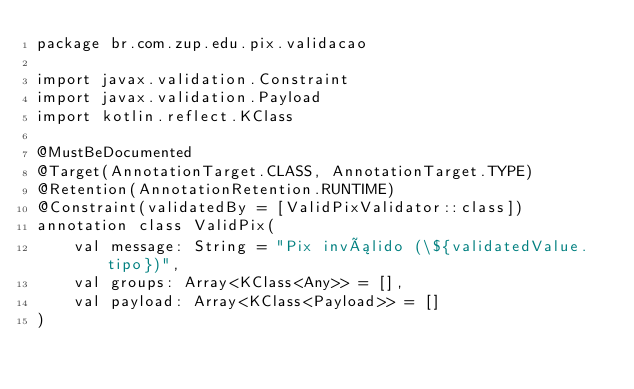<code> <loc_0><loc_0><loc_500><loc_500><_Kotlin_>package br.com.zup.edu.pix.validacao

import javax.validation.Constraint
import javax.validation.Payload
import kotlin.reflect.KClass

@MustBeDocumented
@Target(AnnotationTarget.CLASS, AnnotationTarget.TYPE)
@Retention(AnnotationRetention.RUNTIME)
@Constraint(validatedBy = [ValidPixValidator::class])
annotation class ValidPix(
    val message: String = "Pix inválido (\${validatedValue.tipo})",
    val groups: Array<KClass<Any>> = [],
    val payload: Array<KClass<Payload>> = []
)
</code> 